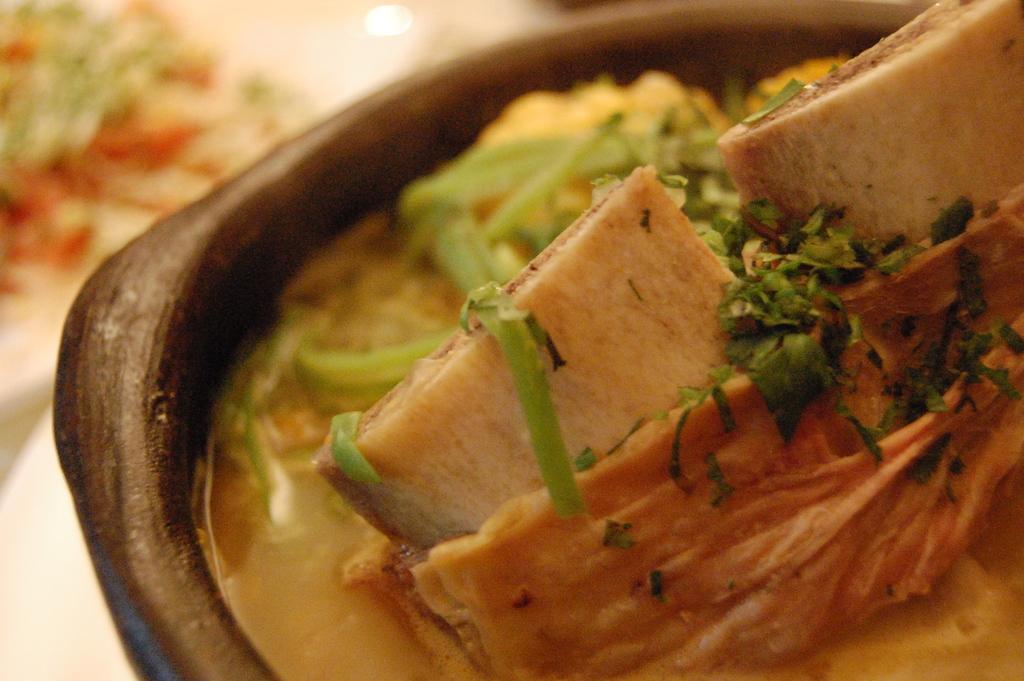Can you describe this image briefly? In this image we can see a bowl containing food placed on the surface. On the left side of the image we can see food placed on a plate. 